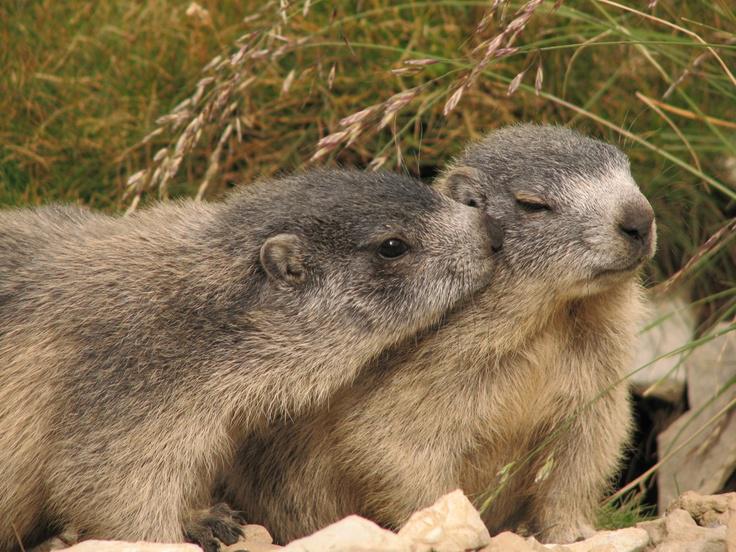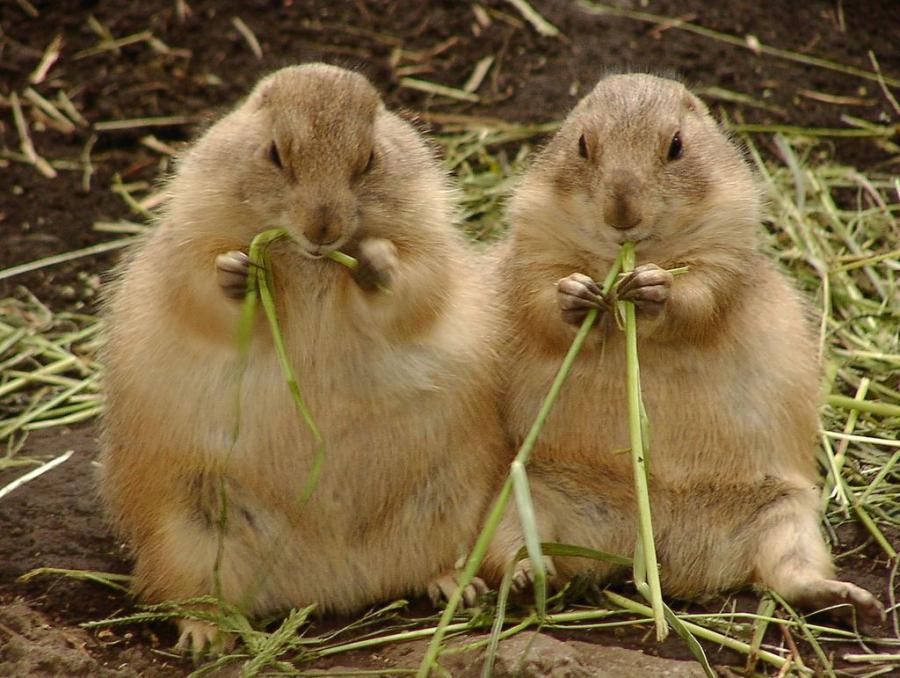The first image is the image on the left, the second image is the image on the right. For the images displayed, is the sentence "At least one image has exactly one animal." factually correct? Answer yes or no. No. The first image is the image on the left, the second image is the image on the right. Assess this claim about the two images: "In at least one of the images, there is just one marmot". Correct or not? Answer yes or no. No. 